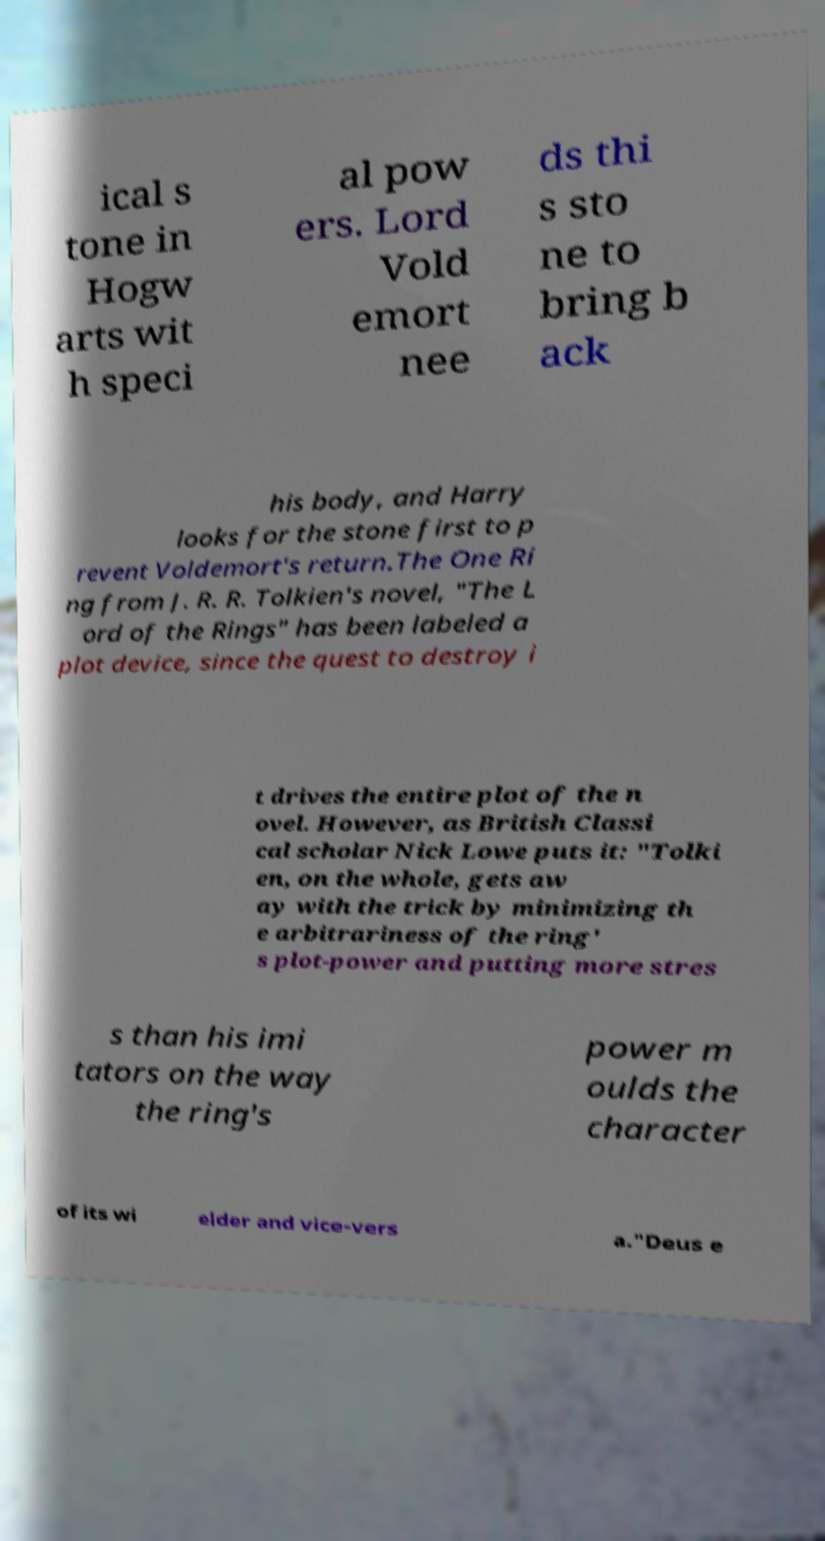Can you read and provide the text displayed in the image?This photo seems to have some interesting text. Can you extract and type it out for me? ical s tone in Hogw arts wit h speci al pow ers. Lord Vold emort nee ds thi s sto ne to bring b ack his body, and Harry looks for the stone first to p revent Voldemort's return.The One Ri ng from J. R. R. Tolkien's novel, "The L ord of the Rings" has been labeled a plot device, since the quest to destroy i t drives the entire plot of the n ovel. However, as British Classi cal scholar Nick Lowe puts it: "Tolki en, on the whole, gets aw ay with the trick by minimizing th e arbitrariness of the ring' s plot-power and putting more stres s than his imi tators on the way the ring's power m oulds the character of its wi elder and vice-vers a."Deus e 